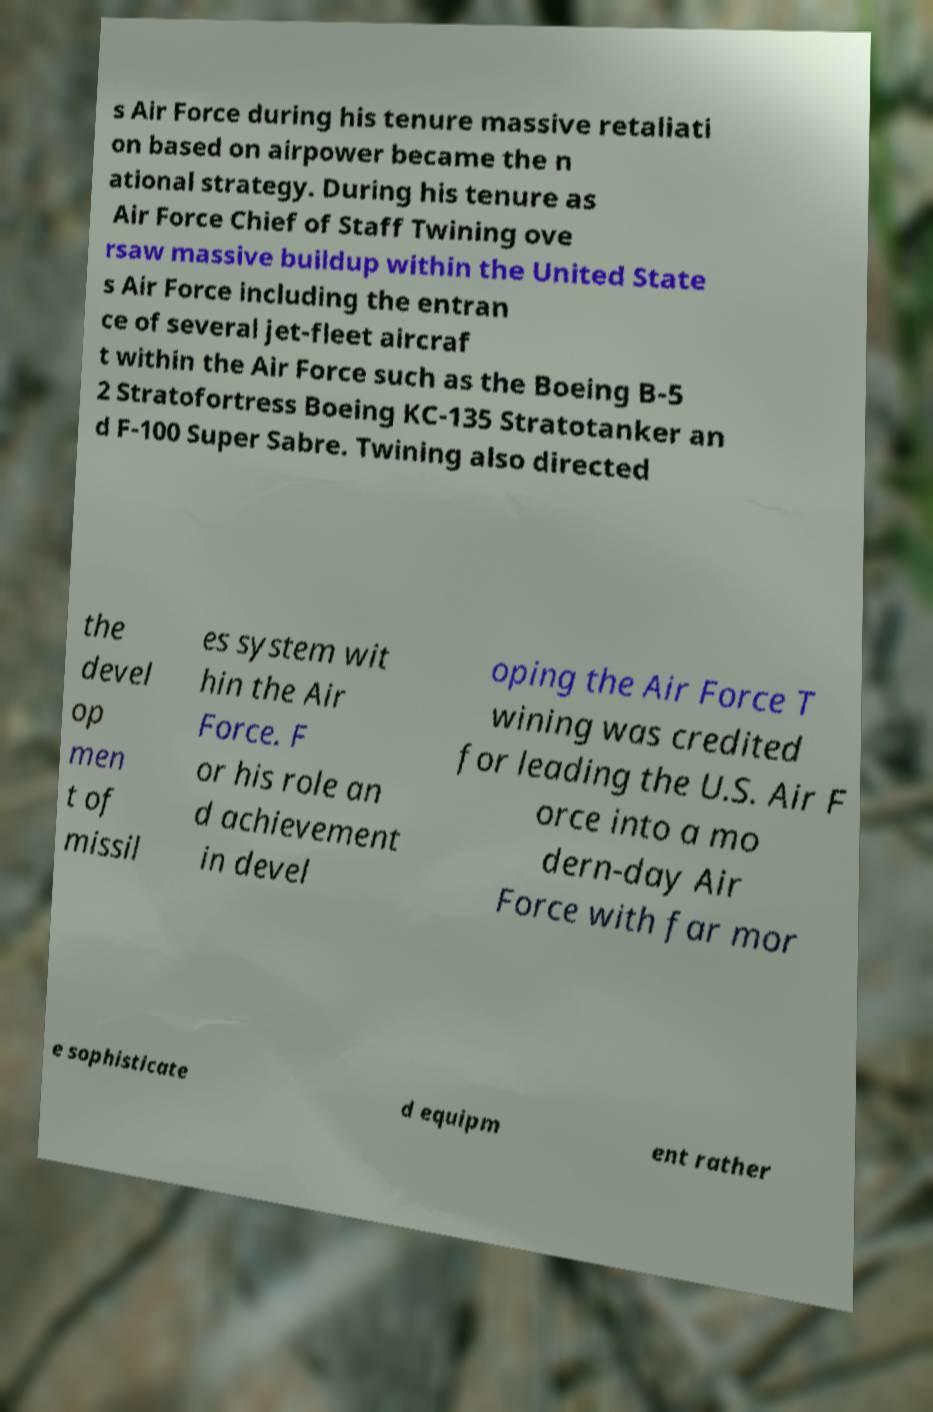There's text embedded in this image that I need extracted. Can you transcribe it verbatim? s Air Force during his tenure massive retaliati on based on airpower became the n ational strategy. During his tenure as Air Force Chief of Staff Twining ove rsaw massive buildup within the United State s Air Force including the entran ce of several jet-fleet aircraf t within the Air Force such as the Boeing B-5 2 Stratofortress Boeing KC-135 Stratotanker an d F-100 Super Sabre. Twining also directed the devel op men t of missil es system wit hin the Air Force. F or his role an d achievement in devel oping the Air Force T wining was credited for leading the U.S. Air F orce into a mo dern-day Air Force with far mor e sophisticate d equipm ent rather 